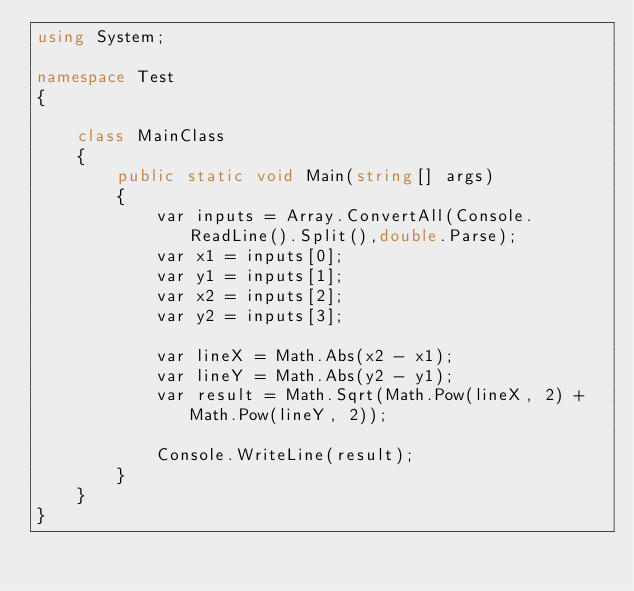<code> <loc_0><loc_0><loc_500><loc_500><_C#_>using System;
 
namespace Test
{
     
    class MainClass
    {
        public static void Main(string[] args)
        {
            var inputs = Array.ConvertAll(Console.ReadLine().Split(),double.Parse);
            var x1 = inputs[0];
            var y1 = inputs[1];
            var x2 = inputs[2];
            var y2 = inputs[3];
 
            var lineX = Math.Abs(x2 - x1);
            var lineY = Math.Abs(y2 - y1);
            var result = Math.Sqrt(Math.Pow(lineX, 2) + Math.Pow(lineY, 2));
 
            Console.WriteLine(result);
        }
    }
}</code> 